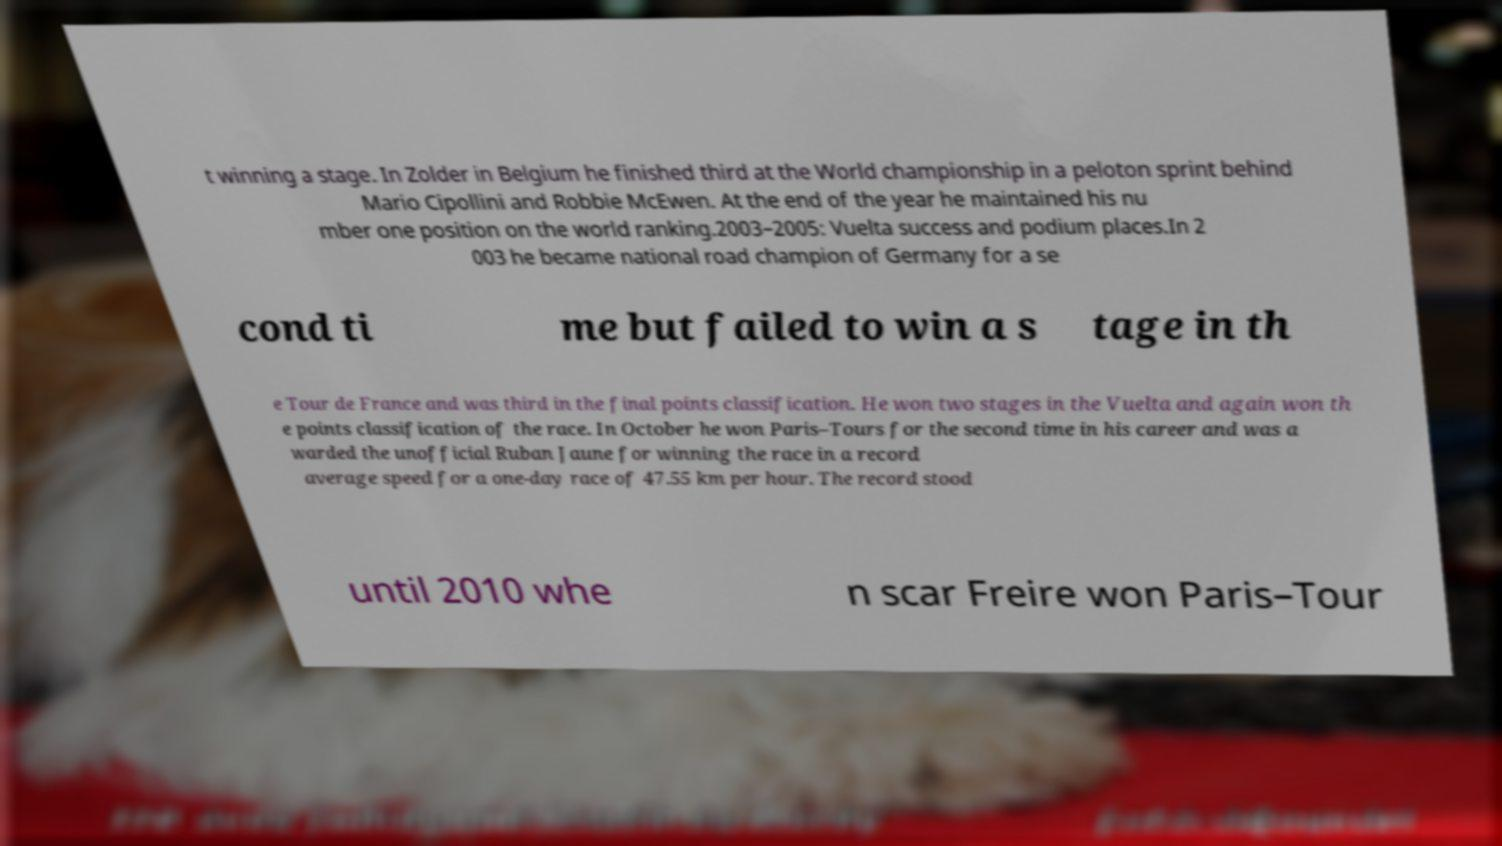What messages or text are displayed in this image? I need them in a readable, typed format. t winning a stage. In Zolder in Belgium he finished third at the World championship in a peloton sprint behind Mario Cipollini and Robbie McEwen. At the end of the year he maintained his nu mber one position on the world ranking.2003–2005: Vuelta success and podium places.In 2 003 he became national road champion of Germany for a se cond ti me but failed to win a s tage in th e Tour de France and was third in the final points classification. He won two stages in the Vuelta and again won th e points classification of the race. In October he won Paris–Tours for the second time in his career and was a warded the unofficial Ruban Jaune for winning the race in a record average speed for a one-day race of 47.55 km per hour. The record stood until 2010 whe n scar Freire won Paris–Tour 